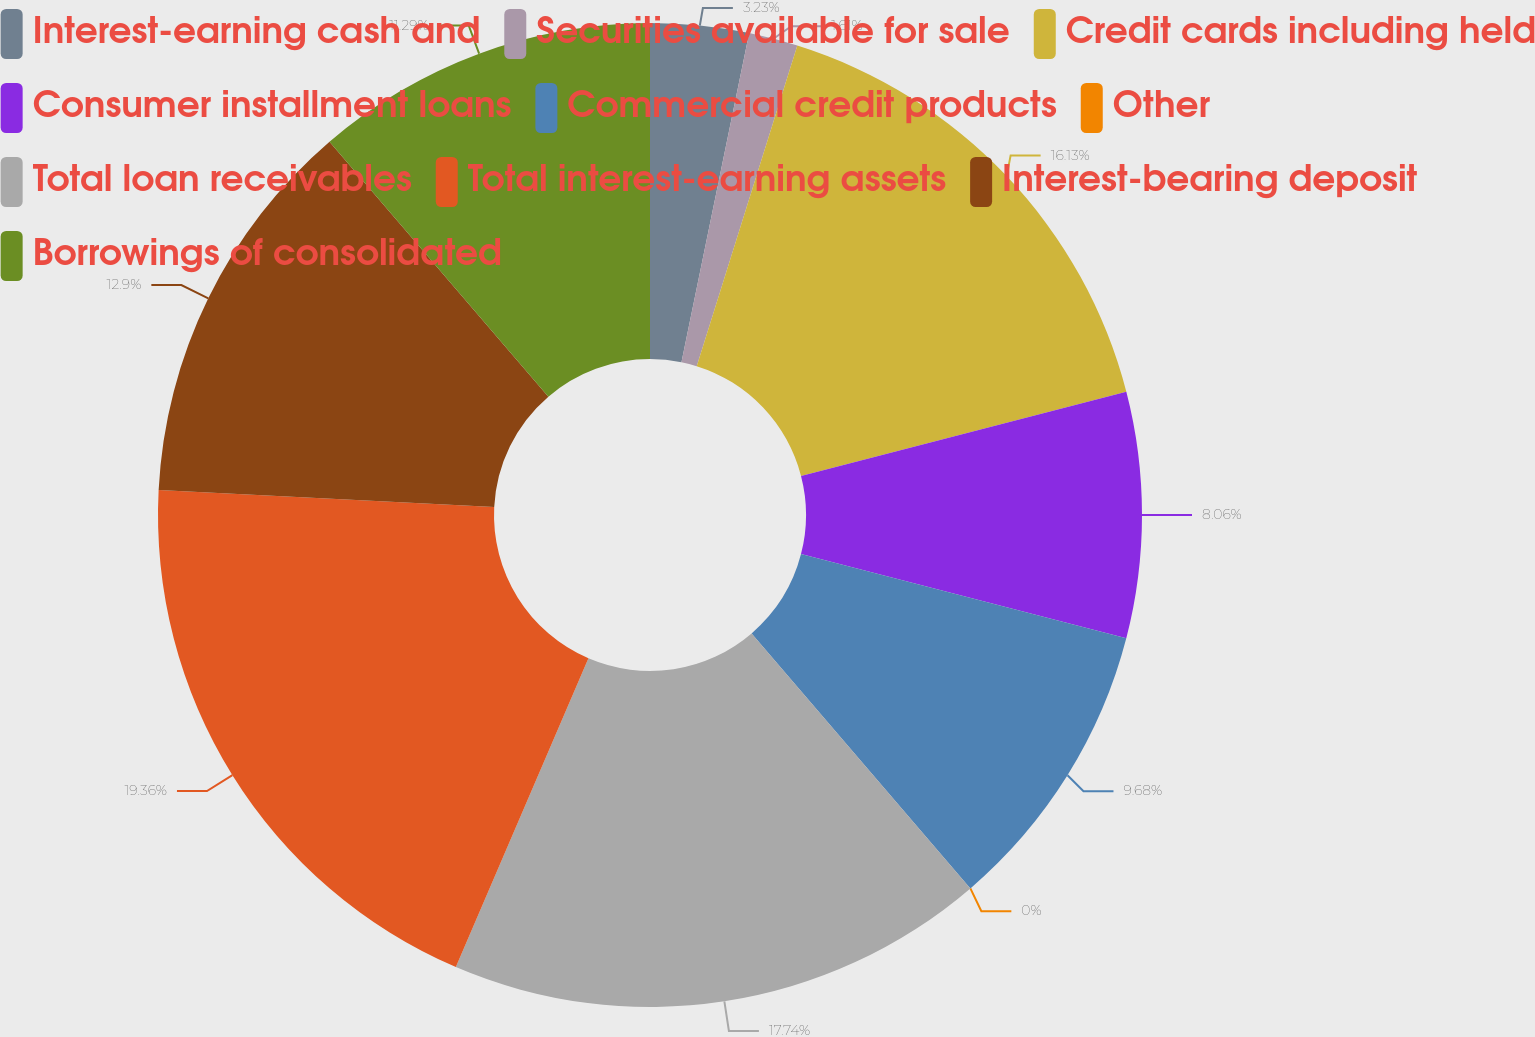<chart> <loc_0><loc_0><loc_500><loc_500><pie_chart><fcel>Interest-earning cash and<fcel>Securities available for sale<fcel>Credit cards including held<fcel>Consumer installment loans<fcel>Commercial credit products<fcel>Other<fcel>Total loan receivables<fcel>Total interest-earning assets<fcel>Interest-bearing deposit<fcel>Borrowings of consolidated<nl><fcel>3.23%<fcel>1.61%<fcel>16.13%<fcel>8.06%<fcel>9.68%<fcel>0.0%<fcel>17.74%<fcel>19.35%<fcel>12.9%<fcel>11.29%<nl></chart> 